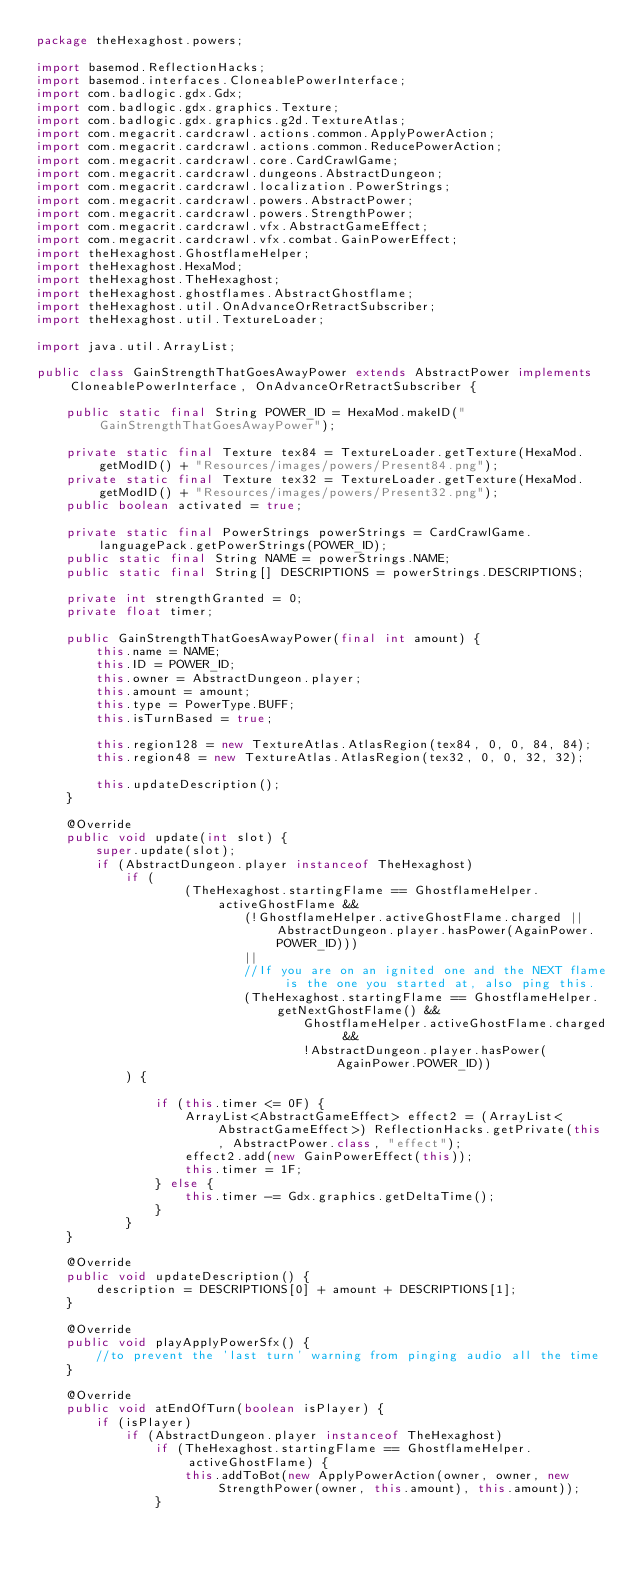<code> <loc_0><loc_0><loc_500><loc_500><_Java_>package theHexaghost.powers;

import basemod.ReflectionHacks;
import basemod.interfaces.CloneablePowerInterface;
import com.badlogic.gdx.Gdx;
import com.badlogic.gdx.graphics.Texture;
import com.badlogic.gdx.graphics.g2d.TextureAtlas;
import com.megacrit.cardcrawl.actions.common.ApplyPowerAction;
import com.megacrit.cardcrawl.actions.common.ReducePowerAction;
import com.megacrit.cardcrawl.core.CardCrawlGame;
import com.megacrit.cardcrawl.dungeons.AbstractDungeon;
import com.megacrit.cardcrawl.localization.PowerStrings;
import com.megacrit.cardcrawl.powers.AbstractPower;
import com.megacrit.cardcrawl.powers.StrengthPower;
import com.megacrit.cardcrawl.vfx.AbstractGameEffect;
import com.megacrit.cardcrawl.vfx.combat.GainPowerEffect;
import theHexaghost.GhostflameHelper;
import theHexaghost.HexaMod;
import theHexaghost.TheHexaghost;
import theHexaghost.ghostflames.AbstractGhostflame;
import theHexaghost.util.OnAdvanceOrRetractSubscriber;
import theHexaghost.util.TextureLoader;

import java.util.ArrayList;

public class GainStrengthThatGoesAwayPower extends AbstractPower implements CloneablePowerInterface, OnAdvanceOrRetractSubscriber {

    public static final String POWER_ID = HexaMod.makeID("GainStrengthThatGoesAwayPower");

    private static final Texture tex84 = TextureLoader.getTexture(HexaMod.getModID() + "Resources/images/powers/Present84.png");
    private static final Texture tex32 = TextureLoader.getTexture(HexaMod.getModID() + "Resources/images/powers/Present32.png");
    public boolean activated = true;

    private static final PowerStrings powerStrings = CardCrawlGame.languagePack.getPowerStrings(POWER_ID);
    public static final String NAME = powerStrings.NAME;
    public static final String[] DESCRIPTIONS = powerStrings.DESCRIPTIONS;

    private int strengthGranted = 0;
    private float timer;

    public GainStrengthThatGoesAwayPower(final int amount) {
        this.name = NAME;
        this.ID = POWER_ID;
        this.owner = AbstractDungeon.player;
        this.amount = amount;
        this.type = PowerType.BUFF;
        this.isTurnBased = true;

        this.region128 = new TextureAtlas.AtlasRegion(tex84, 0, 0, 84, 84);
        this.region48 = new TextureAtlas.AtlasRegion(tex32, 0, 0, 32, 32);

        this.updateDescription();
    }

    @Override
    public void update(int slot) {
        super.update(slot);
        if (AbstractDungeon.player instanceof TheHexaghost)
            if (
                    (TheHexaghost.startingFlame == GhostflameHelper.activeGhostFlame &&
                            (!GhostflameHelper.activeGhostFlame.charged || AbstractDungeon.player.hasPower(AgainPower.POWER_ID)))
                            ||
                            //If you are on an ignited one and the NEXT flame is the one you started at, also ping this.
                            (TheHexaghost.startingFlame == GhostflameHelper.getNextGhostFlame() &&
                                    GhostflameHelper.activeGhostFlame.charged &&
                                    !AbstractDungeon.player.hasPower(AgainPower.POWER_ID))
            ) {

                if (this.timer <= 0F) {
                    ArrayList<AbstractGameEffect> effect2 = (ArrayList<AbstractGameEffect>) ReflectionHacks.getPrivate(this, AbstractPower.class, "effect");
                    effect2.add(new GainPowerEffect(this));
                    this.timer = 1F;
                } else {
                    this.timer -= Gdx.graphics.getDeltaTime();
                }
            }
    }

    @Override
    public void updateDescription() {
        description = DESCRIPTIONS[0] + amount + DESCRIPTIONS[1];
    }

    @Override
    public void playApplyPowerSfx() {
        //to prevent the 'last turn' warning from pinging audio all the time
    }
    
    @Override
    public void atEndOfTurn(boolean isPlayer) {
        if (isPlayer)
            if (AbstractDungeon.player instanceof TheHexaghost)
                if (TheHexaghost.startingFlame == GhostflameHelper.activeGhostFlame) {
                    this.addToBot(new ApplyPowerAction(owner, owner, new StrengthPower(owner, this.amount), this.amount));
                }</code> 